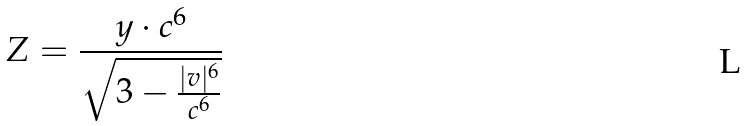Convert formula to latex. <formula><loc_0><loc_0><loc_500><loc_500>Z = \frac { y \cdot c ^ { 6 } } { \sqrt { 3 - \frac { | v | ^ { 6 } } { c ^ { 6 } } } }</formula> 